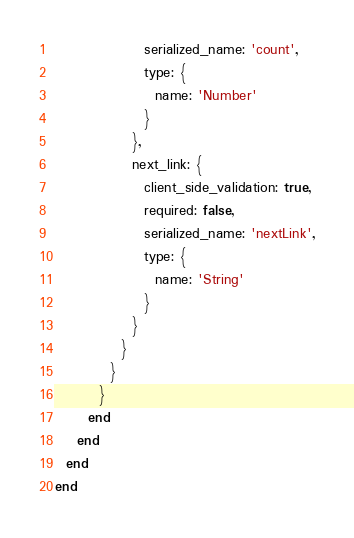<code> <loc_0><loc_0><loc_500><loc_500><_Ruby_>                serialized_name: 'count',
                type: {
                  name: 'Number'
                }
              },
              next_link: {
                client_side_validation: true,
                required: false,
                serialized_name: 'nextLink',
                type: {
                  name: 'String'
                }
              }
            }
          }
        }
      end
    end
  end
end
</code> 